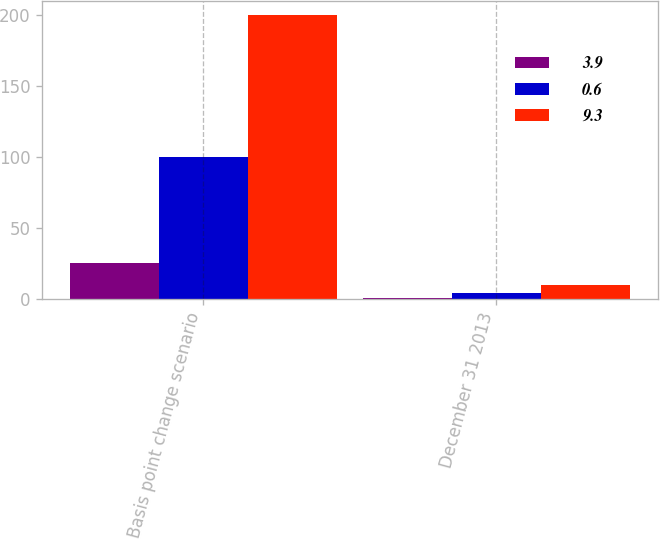Convert chart. <chart><loc_0><loc_0><loc_500><loc_500><stacked_bar_chart><ecel><fcel>Basis point change scenario<fcel>December 31 2013<nl><fcel>3.9<fcel>25<fcel>0.6<nl><fcel>0.6<fcel>100<fcel>3.9<nl><fcel>9.3<fcel>200<fcel>9.3<nl></chart> 